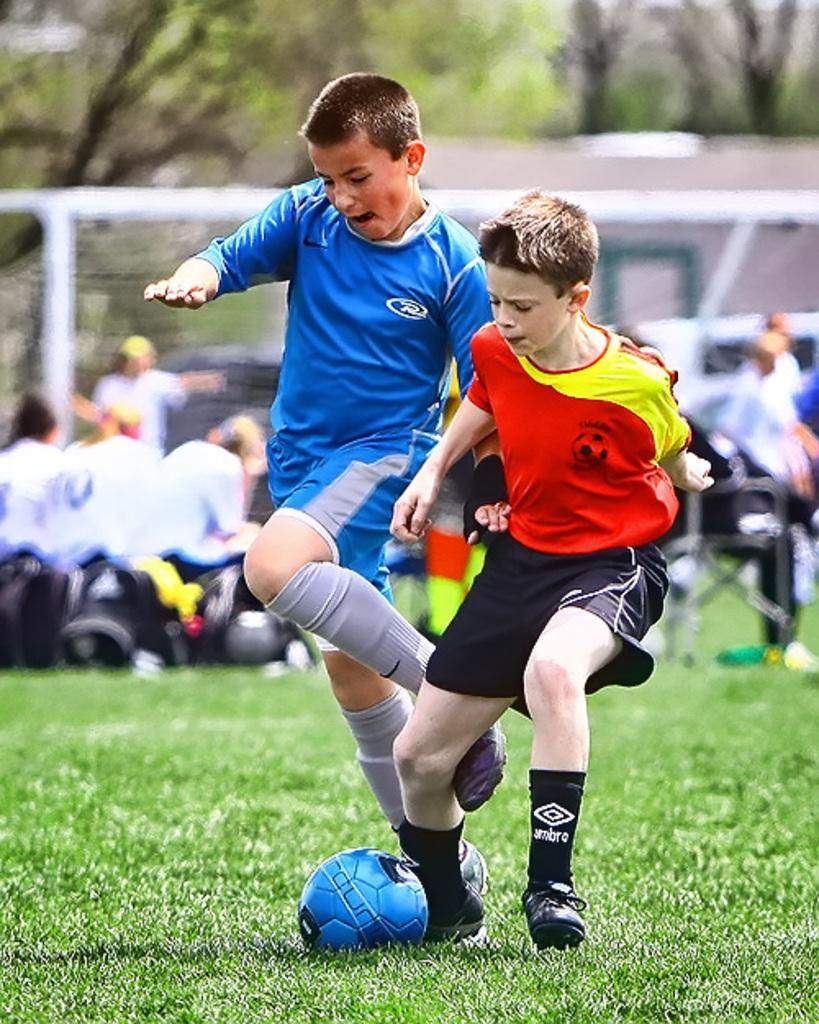How many boys are present in the image? There are two boys in the image. What are the boys doing in the image? The boys are on a ground, which suggests they might be playing or engaging in some activity. What object is visible in the image that is commonly used in sports? There is a football in the image. What can be seen in the background of the image? There are people and trees in the background of the image. How many dogs are present in the image? There are no dogs present in the image. What type of headwear are the boys wearing in the image? The image does not show the boys wearing any headwear. 